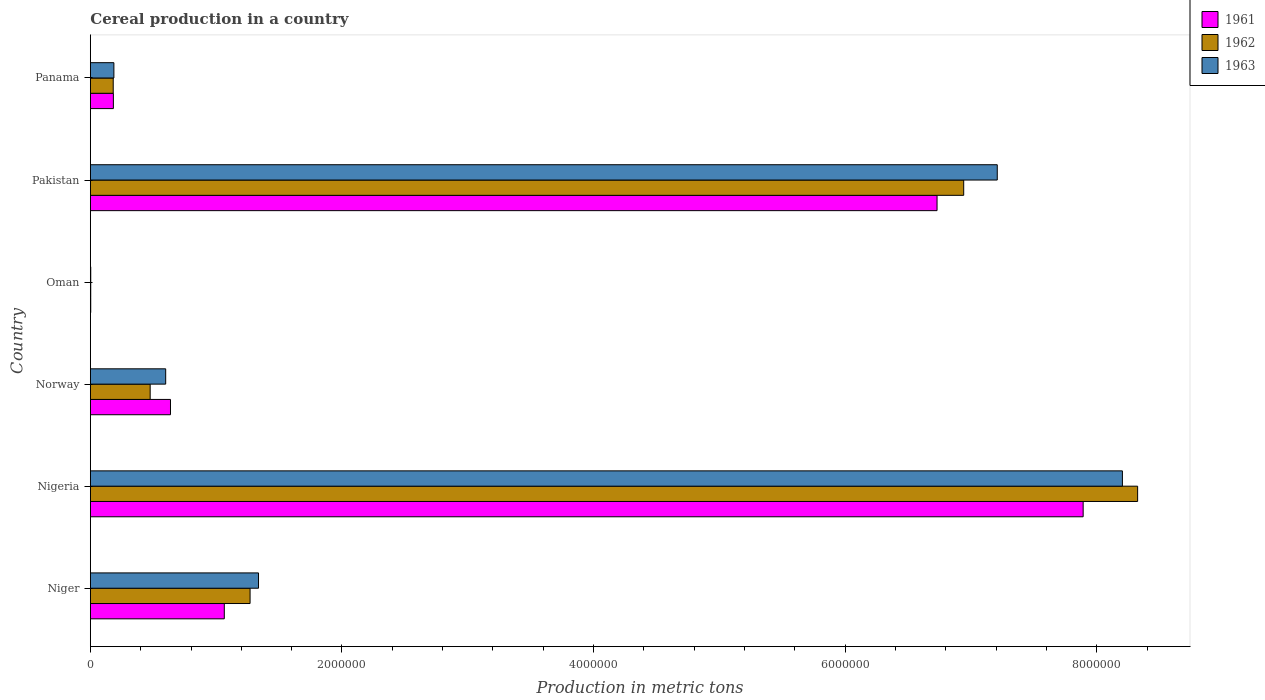How many different coloured bars are there?
Your answer should be very brief. 3. How many bars are there on the 6th tick from the top?
Keep it short and to the point. 3. What is the label of the 1st group of bars from the top?
Offer a very short reply. Panama. In how many cases, is the number of bars for a given country not equal to the number of legend labels?
Make the answer very short. 0. What is the total cereal production in 1961 in Panama?
Your response must be concise. 1.83e+05. Across all countries, what is the maximum total cereal production in 1963?
Keep it short and to the point. 8.20e+06. Across all countries, what is the minimum total cereal production in 1962?
Offer a terse response. 2900. In which country was the total cereal production in 1962 maximum?
Offer a very short reply. Nigeria. In which country was the total cereal production in 1961 minimum?
Keep it short and to the point. Oman. What is the total total cereal production in 1962 in the graph?
Give a very brief answer. 1.72e+07. What is the difference between the total cereal production in 1961 in Oman and that in Panama?
Offer a terse response. -1.80e+05. What is the difference between the total cereal production in 1962 in Norway and the total cereal production in 1963 in Niger?
Provide a short and direct response. -8.61e+05. What is the average total cereal production in 1963 per country?
Give a very brief answer. 2.92e+06. What is the difference between the total cereal production in 1962 and total cereal production in 1963 in Panama?
Offer a very short reply. -5407. In how many countries, is the total cereal production in 1961 greater than 6400000 metric tons?
Keep it short and to the point. 2. What is the ratio of the total cereal production in 1962 in Nigeria to that in Pakistan?
Provide a short and direct response. 1.2. Is the total cereal production in 1961 in Nigeria less than that in Panama?
Your answer should be very brief. No. Is the difference between the total cereal production in 1962 in Niger and Norway greater than the difference between the total cereal production in 1963 in Niger and Norway?
Give a very brief answer. Yes. What is the difference between the highest and the second highest total cereal production in 1963?
Give a very brief answer. 9.95e+05. What is the difference between the highest and the lowest total cereal production in 1963?
Ensure brevity in your answer.  8.20e+06. What does the 1st bar from the bottom in Pakistan represents?
Your answer should be compact. 1961. Is it the case that in every country, the sum of the total cereal production in 1961 and total cereal production in 1962 is greater than the total cereal production in 1963?
Ensure brevity in your answer.  Yes. Are all the bars in the graph horizontal?
Your answer should be compact. Yes. How many countries are there in the graph?
Your response must be concise. 6. What is the difference between two consecutive major ticks on the X-axis?
Your response must be concise. 2.00e+06. Are the values on the major ticks of X-axis written in scientific E-notation?
Give a very brief answer. No. Does the graph contain any zero values?
Provide a succinct answer. No. Where does the legend appear in the graph?
Your answer should be very brief. Top right. What is the title of the graph?
Offer a very short reply. Cereal production in a country. Does "1977" appear as one of the legend labels in the graph?
Offer a terse response. No. What is the label or title of the X-axis?
Offer a very short reply. Production in metric tons. What is the label or title of the Y-axis?
Provide a succinct answer. Country. What is the Production in metric tons of 1961 in Niger?
Make the answer very short. 1.06e+06. What is the Production in metric tons of 1962 in Niger?
Offer a terse response. 1.27e+06. What is the Production in metric tons in 1963 in Niger?
Your answer should be very brief. 1.34e+06. What is the Production in metric tons of 1961 in Nigeria?
Offer a terse response. 7.89e+06. What is the Production in metric tons of 1962 in Nigeria?
Your response must be concise. 8.32e+06. What is the Production in metric tons in 1963 in Nigeria?
Give a very brief answer. 8.20e+06. What is the Production in metric tons in 1961 in Norway?
Provide a succinct answer. 6.37e+05. What is the Production in metric tons of 1962 in Norway?
Offer a very short reply. 4.75e+05. What is the Production in metric tons in 1963 in Norway?
Offer a very short reply. 5.99e+05. What is the Production in metric tons of 1961 in Oman?
Ensure brevity in your answer.  2900. What is the Production in metric tons in 1962 in Oman?
Offer a very short reply. 2900. What is the Production in metric tons in 1963 in Oman?
Provide a succinct answer. 3000. What is the Production in metric tons of 1961 in Pakistan?
Your answer should be very brief. 6.73e+06. What is the Production in metric tons in 1962 in Pakistan?
Your answer should be compact. 6.94e+06. What is the Production in metric tons in 1963 in Pakistan?
Offer a terse response. 7.21e+06. What is the Production in metric tons of 1961 in Panama?
Keep it short and to the point. 1.83e+05. What is the Production in metric tons in 1962 in Panama?
Your answer should be very brief. 1.82e+05. What is the Production in metric tons of 1963 in Panama?
Your response must be concise. 1.87e+05. Across all countries, what is the maximum Production in metric tons of 1961?
Your answer should be very brief. 7.89e+06. Across all countries, what is the maximum Production in metric tons in 1962?
Give a very brief answer. 8.32e+06. Across all countries, what is the maximum Production in metric tons of 1963?
Keep it short and to the point. 8.20e+06. Across all countries, what is the minimum Production in metric tons of 1961?
Keep it short and to the point. 2900. Across all countries, what is the minimum Production in metric tons in 1962?
Keep it short and to the point. 2900. Across all countries, what is the minimum Production in metric tons of 1963?
Keep it short and to the point. 3000. What is the total Production in metric tons in 1961 in the graph?
Ensure brevity in your answer.  1.65e+07. What is the total Production in metric tons in 1962 in the graph?
Give a very brief answer. 1.72e+07. What is the total Production in metric tons in 1963 in the graph?
Your answer should be very brief. 1.75e+07. What is the difference between the Production in metric tons of 1961 in Niger and that in Nigeria?
Your answer should be very brief. -6.83e+06. What is the difference between the Production in metric tons in 1962 in Niger and that in Nigeria?
Provide a short and direct response. -7.05e+06. What is the difference between the Production in metric tons of 1963 in Niger and that in Nigeria?
Your answer should be very brief. -6.87e+06. What is the difference between the Production in metric tons of 1961 in Niger and that in Norway?
Provide a succinct answer. 4.28e+05. What is the difference between the Production in metric tons in 1962 in Niger and that in Norway?
Make the answer very short. 7.94e+05. What is the difference between the Production in metric tons of 1963 in Niger and that in Norway?
Offer a terse response. 7.38e+05. What is the difference between the Production in metric tons of 1961 in Niger and that in Oman?
Your answer should be compact. 1.06e+06. What is the difference between the Production in metric tons in 1962 in Niger and that in Oman?
Offer a very short reply. 1.27e+06. What is the difference between the Production in metric tons in 1963 in Niger and that in Oman?
Offer a terse response. 1.33e+06. What is the difference between the Production in metric tons of 1961 in Niger and that in Pakistan?
Your response must be concise. -5.67e+06. What is the difference between the Production in metric tons in 1962 in Niger and that in Pakistan?
Ensure brevity in your answer.  -5.67e+06. What is the difference between the Production in metric tons of 1963 in Niger and that in Pakistan?
Provide a succinct answer. -5.87e+06. What is the difference between the Production in metric tons in 1961 in Niger and that in Panama?
Ensure brevity in your answer.  8.82e+05. What is the difference between the Production in metric tons of 1962 in Niger and that in Panama?
Ensure brevity in your answer.  1.09e+06. What is the difference between the Production in metric tons of 1963 in Niger and that in Panama?
Ensure brevity in your answer.  1.15e+06. What is the difference between the Production in metric tons of 1961 in Nigeria and that in Norway?
Give a very brief answer. 7.25e+06. What is the difference between the Production in metric tons of 1962 in Nigeria and that in Norway?
Offer a terse response. 7.85e+06. What is the difference between the Production in metric tons in 1963 in Nigeria and that in Norway?
Provide a short and direct response. 7.60e+06. What is the difference between the Production in metric tons of 1961 in Nigeria and that in Oman?
Provide a short and direct response. 7.89e+06. What is the difference between the Production in metric tons of 1962 in Nigeria and that in Oman?
Your answer should be very brief. 8.32e+06. What is the difference between the Production in metric tons of 1963 in Nigeria and that in Oman?
Provide a succinct answer. 8.20e+06. What is the difference between the Production in metric tons of 1961 in Nigeria and that in Pakistan?
Give a very brief answer. 1.16e+06. What is the difference between the Production in metric tons in 1962 in Nigeria and that in Pakistan?
Ensure brevity in your answer.  1.38e+06. What is the difference between the Production in metric tons of 1963 in Nigeria and that in Pakistan?
Your response must be concise. 9.95e+05. What is the difference between the Production in metric tons of 1961 in Nigeria and that in Panama?
Offer a terse response. 7.71e+06. What is the difference between the Production in metric tons of 1962 in Nigeria and that in Panama?
Provide a succinct answer. 8.14e+06. What is the difference between the Production in metric tons of 1963 in Nigeria and that in Panama?
Offer a terse response. 8.02e+06. What is the difference between the Production in metric tons in 1961 in Norway and that in Oman?
Provide a succinct answer. 6.34e+05. What is the difference between the Production in metric tons of 1962 in Norway and that in Oman?
Give a very brief answer. 4.72e+05. What is the difference between the Production in metric tons of 1963 in Norway and that in Oman?
Provide a short and direct response. 5.96e+05. What is the difference between the Production in metric tons of 1961 in Norway and that in Pakistan?
Offer a terse response. -6.09e+06. What is the difference between the Production in metric tons of 1962 in Norway and that in Pakistan?
Keep it short and to the point. -6.47e+06. What is the difference between the Production in metric tons of 1963 in Norway and that in Pakistan?
Offer a terse response. -6.61e+06. What is the difference between the Production in metric tons in 1961 in Norway and that in Panama?
Your response must be concise. 4.54e+05. What is the difference between the Production in metric tons of 1962 in Norway and that in Panama?
Offer a terse response. 2.94e+05. What is the difference between the Production in metric tons of 1963 in Norway and that in Panama?
Provide a succinct answer. 4.12e+05. What is the difference between the Production in metric tons in 1961 in Oman and that in Pakistan?
Provide a succinct answer. -6.73e+06. What is the difference between the Production in metric tons of 1962 in Oman and that in Pakistan?
Provide a succinct answer. -6.94e+06. What is the difference between the Production in metric tons in 1963 in Oman and that in Pakistan?
Provide a short and direct response. -7.21e+06. What is the difference between the Production in metric tons of 1961 in Oman and that in Panama?
Keep it short and to the point. -1.80e+05. What is the difference between the Production in metric tons of 1962 in Oman and that in Panama?
Provide a short and direct response. -1.79e+05. What is the difference between the Production in metric tons of 1963 in Oman and that in Panama?
Make the answer very short. -1.84e+05. What is the difference between the Production in metric tons in 1961 in Pakistan and that in Panama?
Ensure brevity in your answer.  6.55e+06. What is the difference between the Production in metric tons in 1962 in Pakistan and that in Panama?
Provide a short and direct response. 6.76e+06. What is the difference between the Production in metric tons of 1963 in Pakistan and that in Panama?
Ensure brevity in your answer.  7.02e+06. What is the difference between the Production in metric tons of 1961 in Niger and the Production in metric tons of 1962 in Nigeria?
Provide a succinct answer. -7.26e+06. What is the difference between the Production in metric tons of 1961 in Niger and the Production in metric tons of 1963 in Nigeria?
Provide a succinct answer. -7.14e+06. What is the difference between the Production in metric tons in 1962 in Niger and the Production in metric tons in 1963 in Nigeria?
Give a very brief answer. -6.93e+06. What is the difference between the Production in metric tons in 1961 in Niger and the Production in metric tons in 1962 in Norway?
Your answer should be very brief. 5.89e+05. What is the difference between the Production in metric tons of 1961 in Niger and the Production in metric tons of 1963 in Norway?
Provide a succinct answer. 4.66e+05. What is the difference between the Production in metric tons in 1962 in Niger and the Production in metric tons in 1963 in Norway?
Your answer should be very brief. 6.71e+05. What is the difference between the Production in metric tons in 1961 in Niger and the Production in metric tons in 1962 in Oman?
Provide a short and direct response. 1.06e+06. What is the difference between the Production in metric tons in 1961 in Niger and the Production in metric tons in 1963 in Oman?
Offer a very short reply. 1.06e+06. What is the difference between the Production in metric tons in 1962 in Niger and the Production in metric tons in 1963 in Oman?
Ensure brevity in your answer.  1.27e+06. What is the difference between the Production in metric tons in 1961 in Niger and the Production in metric tons in 1962 in Pakistan?
Offer a very short reply. -5.88e+06. What is the difference between the Production in metric tons in 1961 in Niger and the Production in metric tons in 1963 in Pakistan?
Offer a very short reply. -6.14e+06. What is the difference between the Production in metric tons of 1962 in Niger and the Production in metric tons of 1963 in Pakistan?
Your answer should be very brief. -5.94e+06. What is the difference between the Production in metric tons of 1961 in Niger and the Production in metric tons of 1962 in Panama?
Keep it short and to the point. 8.83e+05. What is the difference between the Production in metric tons in 1961 in Niger and the Production in metric tons in 1963 in Panama?
Provide a short and direct response. 8.78e+05. What is the difference between the Production in metric tons of 1962 in Niger and the Production in metric tons of 1963 in Panama?
Offer a very short reply. 1.08e+06. What is the difference between the Production in metric tons in 1961 in Nigeria and the Production in metric tons in 1962 in Norway?
Give a very brief answer. 7.42e+06. What is the difference between the Production in metric tons in 1961 in Nigeria and the Production in metric tons in 1963 in Norway?
Keep it short and to the point. 7.29e+06. What is the difference between the Production in metric tons of 1962 in Nigeria and the Production in metric tons of 1963 in Norway?
Offer a very short reply. 7.73e+06. What is the difference between the Production in metric tons of 1961 in Nigeria and the Production in metric tons of 1962 in Oman?
Your answer should be compact. 7.89e+06. What is the difference between the Production in metric tons of 1961 in Nigeria and the Production in metric tons of 1963 in Oman?
Your response must be concise. 7.89e+06. What is the difference between the Production in metric tons of 1962 in Nigeria and the Production in metric tons of 1963 in Oman?
Your answer should be very brief. 8.32e+06. What is the difference between the Production in metric tons of 1961 in Nigeria and the Production in metric tons of 1962 in Pakistan?
Provide a short and direct response. 9.49e+05. What is the difference between the Production in metric tons in 1961 in Nigeria and the Production in metric tons in 1963 in Pakistan?
Offer a very short reply. 6.83e+05. What is the difference between the Production in metric tons of 1962 in Nigeria and the Production in metric tons of 1963 in Pakistan?
Your answer should be compact. 1.12e+06. What is the difference between the Production in metric tons in 1961 in Nigeria and the Production in metric tons in 1962 in Panama?
Your answer should be compact. 7.71e+06. What is the difference between the Production in metric tons of 1961 in Nigeria and the Production in metric tons of 1963 in Panama?
Offer a very short reply. 7.70e+06. What is the difference between the Production in metric tons of 1962 in Nigeria and the Production in metric tons of 1963 in Panama?
Offer a very short reply. 8.14e+06. What is the difference between the Production in metric tons in 1961 in Norway and the Production in metric tons in 1962 in Oman?
Ensure brevity in your answer.  6.34e+05. What is the difference between the Production in metric tons in 1961 in Norway and the Production in metric tons in 1963 in Oman?
Provide a short and direct response. 6.34e+05. What is the difference between the Production in metric tons of 1962 in Norway and the Production in metric tons of 1963 in Oman?
Offer a terse response. 4.72e+05. What is the difference between the Production in metric tons of 1961 in Norway and the Production in metric tons of 1962 in Pakistan?
Keep it short and to the point. -6.30e+06. What is the difference between the Production in metric tons in 1961 in Norway and the Production in metric tons in 1963 in Pakistan?
Your answer should be very brief. -6.57e+06. What is the difference between the Production in metric tons of 1962 in Norway and the Production in metric tons of 1963 in Pakistan?
Your answer should be compact. -6.73e+06. What is the difference between the Production in metric tons in 1961 in Norway and the Production in metric tons in 1962 in Panama?
Provide a succinct answer. 4.55e+05. What is the difference between the Production in metric tons of 1961 in Norway and the Production in metric tons of 1963 in Panama?
Provide a short and direct response. 4.50e+05. What is the difference between the Production in metric tons of 1962 in Norway and the Production in metric tons of 1963 in Panama?
Provide a short and direct response. 2.88e+05. What is the difference between the Production in metric tons of 1961 in Oman and the Production in metric tons of 1962 in Pakistan?
Your answer should be compact. -6.94e+06. What is the difference between the Production in metric tons of 1961 in Oman and the Production in metric tons of 1963 in Pakistan?
Make the answer very short. -7.21e+06. What is the difference between the Production in metric tons of 1962 in Oman and the Production in metric tons of 1963 in Pakistan?
Your response must be concise. -7.21e+06. What is the difference between the Production in metric tons in 1961 in Oman and the Production in metric tons in 1962 in Panama?
Provide a succinct answer. -1.79e+05. What is the difference between the Production in metric tons in 1961 in Oman and the Production in metric tons in 1963 in Panama?
Ensure brevity in your answer.  -1.84e+05. What is the difference between the Production in metric tons in 1962 in Oman and the Production in metric tons in 1963 in Panama?
Make the answer very short. -1.84e+05. What is the difference between the Production in metric tons of 1961 in Pakistan and the Production in metric tons of 1962 in Panama?
Your response must be concise. 6.55e+06. What is the difference between the Production in metric tons of 1961 in Pakistan and the Production in metric tons of 1963 in Panama?
Offer a terse response. 6.54e+06. What is the difference between the Production in metric tons of 1962 in Pakistan and the Production in metric tons of 1963 in Panama?
Make the answer very short. 6.75e+06. What is the average Production in metric tons of 1961 per country?
Ensure brevity in your answer.  2.75e+06. What is the average Production in metric tons in 1962 per country?
Your answer should be compact. 2.87e+06. What is the average Production in metric tons of 1963 per country?
Keep it short and to the point. 2.92e+06. What is the difference between the Production in metric tons in 1961 and Production in metric tons in 1962 in Niger?
Provide a succinct answer. -2.05e+05. What is the difference between the Production in metric tons in 1961 and Production in metric tons in 1963 in Niger?
Give a very brief answer. -2.72e+05. What is the difference between the Production in metric tons in 1962 and Production in metric tons in 1963 in Niger?
Provide a succinct answer. -6.71e+04. What is the difference between the Production in metric tons in 1961 and Production in metric tons in 1962 in Nigeria?
Give a very brief answer. -4.33e+05. What is the difference between the Production in metric tons of 1961 and Production in metric tons of 1963 in Nigeria?
Ensure brevity in your answer.  -3.12e+05. What is the difference between the Production in metric tons of 1962 and Production in metric tons of 1963 in Nigeria?
Provide a short and direct response. 1.21e+05. What is the difference between the Production in metric tons of 1961 and Production in metric tons of 1962 in Norway?
Provide a succinct answer. 1.61e+05. What is the difference between the Production in metric tons in 1961 and Production in metric tons in 1963 in Norway?
Provide a short and direct response. 3.81e+04. What is the difference between the Production in metric tons in 1962 and Production in metric tons in 1963 in Norway?
Your answer should be very brief. -1.23e+05. What is the difference between the Production in metric tons of 1961 and Production in metric tons of 1963 in Oman?
Keep it short and to the point. -100. What is the difference between the Production in metric tons in 1962 and Production in metric tons in 1963 in Oman?
Provide a succinct answer. -100. What is the difference between the Production in metric tons of 1961 and Production in metric tons of 1962 in Pakistan?
Your answer should be very brief. -2.12e+05. What is the difference between the Production in metric tons in 1961 and Production in metric tons in 1963 in Pakistan?
Your answer should be compact. -4.79e+05. What is the difference between the Production in metric tons of 1962 and Production in metric tons of 1963 in Pakistan?
Keep it short and to the point. -2.67e+05. What is the difference between the Production in metric tons in 1961 and Production in metric tons in 1962 in Panama?
Provide a short and direct response. 1297. What is the difference between the Production in metric tons in 1961 and Production in metric tons in 1963 in Panama?
Offer a very short reply. -4110. What is the difference between the Production in metric tons in 1962 and Production in metric tons in 1963 in Panama?
Offer a very short reply. -5407. What is the ratio of the Production in metric tons in 1961 in Niger to that in Nigeria?
Make the answer very short. 0.13. What is the ratio of the Production in metric tons of 1962 in Niger to that in Nigeria?
Your answer should be very brief. 0.15. What is the ratio of the Production in metric tons in 1963 in Niger to that in Nigeria?
Your response must be concise. 0.16. What is the ratio of the Production in metric tons of 1961 in Niger to that in Norway?
Offer a terse response. 1.67. What is the ratio of the Production in metric tons of 1962 in Niger to that in Norway?
Keep it short and to the point. 2.67. What is the ratio of the Production in metric tons in 1963 in Niger to that in Norway?
Your response must be concise. 2.23. What is the ratio of the Production in metric tons of 1961 in Niger to that in Oman?
Keep it short and to the point. 367.08. What is the ratio of the Production in metric tons in 1962 in Niger to that in Oman?
Make the answer very short. 437.72. What is the ratio of the Production in metric tons of 1963 in Niger to that in Oman?
Ensure brevity in your answer.  445.48. What is the ratio of the Production in metric tons of 1961 in Niger to that in Pakistan?
Your response must be concise. 0.16. What is the ratio of the Production in metric tons of 1962 in Niger to that in Pakistan?
Make the answer very short. 0.18. What is the ratio of the Production in metric tons in 1963 in Niger to that in Pakistan?
Your response must be concise. 0.19. What is the ratio of the Production in metric tons in 1961 in Niger to that in Panama?
Provide a short and direct response. 5.82. What is the ratio of the Production in metric tons of 1962 in Niger to that in Panama?
Offer a very short reply. 6.99. What is the ratio of the Production in metric tons of 1963 in Niger to that in Panama?
Your answer should be compact. 7.15. What is the ratio of the Production in metric tons in 1961 in Nigeria to that in Norway?
Make the answer very short. 12.39. What is the ratio of the Production in metric tons of 1962 in Nigeria to that in Norway?
Offer a terse response. 17.51. What is the ratio of the Production in metric tons of 1963 in Nigeria to that in Norway?
Make the answer very short. 13.7. What is the ratio of the Production in metric tons of 1961 in Nigeria to that in Oman?
Give a very brief answer. 2721.03. What is the ratio of the Production in metric tons of 1962 in Nigeria to that in Oman?
Provide a succinct answer. 2870.34. What is the ratio of the Production in metric tons of 1963 in Nigeria to that in Oman?
Your answer should be compact. 2734.33. What is the ratio of the Production in metric tons of 1961 in Nigeria to that in Pakistan?
Make the answer very short. 1.17. What is the ratio of the Production in metric tons in 1962 in Nigeria to that in Pakistan?
Make the answer very short. 1.2. What is the ratio of the Production in metric tons of 1963 in Nigeria to that in Pakistan?
Ensure brevity in your answer.  1.14. What is the ratio of the Production in metric tons of 1961 in Nigeria to that in Panama?
Offer a terse response. 43.15. What is the ratio of the Production in metric tons in 1962 in Nigeria to that in Panama?
Your answer should be compact. 45.84. What is the ratio of the Production in metric tons in 1963 in Nigeria to that in Panama?
Provide a short and direct response. 43.87. What is the ratio of the Production in metric tons of 1961 in Norway to that in Oman?
Your response must be concise. 219.6. What is the ratio of the Production in metric tons in 1962 in Norway to that in Oman?
Your response must be concise. 163.93. What is the ratio of the Production in metric tons of 1963 in Norway to that in Oman?
Ensure brevity in your answer.  199.58. What is the ratio of the Production in metric tons of 1961 in Norway to that in Pakistan?
Provide a succinct answer. 0.09. What is the ratio of the Production in metric tons in 1962 in Norway to that in Pakistan?
Give a very brief answer. 0.07. What is the ratio of the Production in metric tons in 1963 in Norway to that in Pakistan?
Offer a very short reply. 0.08. What is the ratio of the Production in metric tons in 1961 in Norway to that in Panama?
Offer a very short reply. 3.48. What is the ratio of the Production in metric tons of 1962 in Norway to that in Panama?
Offer a terse response. 2.62. What is the ratio of the Production in metric tons in 1963 in Norway to that in Panama?
Make the answer very short. 3.2. What is the ratio of the Production in metric tons of 1961 in Oman to that in Pakistan?
Ensure brevity in your answer.  0. What is the ratio of the Production in metric tons of 1961 in Oman to that in Panama?
Offer a very short reply. 0.02. What is the ratio of the Production in metric tons of 1962 in Oman to that in Panama?
Offer a very short reply. 0.02. What is the ratio of the Production in metric tons of 1963 in Oman to that in Panama?
Give a very brief answer. 0.02. What is the ratio of the Production in metric tons of 1961 in Pakistan to that in Panama?
Provide a succinct answer. 36.8. What is the ratio of the Production in metric tons of 1962 in Pakistan to that in Panama?
Ensure brevity in your answer.  38.23. What is the ratio of the Production in metric tons of 1963 in Pakistan to that in Panama?
Offer a terse response. 38.55. What is the difference between the highest and the second highest Production in metric tons of 1961?
Offer a very short reply. 1.16e+06. What is the difference between the highest and the second highest Production in metric tons in 1962?
Ensure brevity in your answer.  1.38e+06. What is the difference between the highest and the second highest Production in metric tons of 1963?
Your response must be concise. 9.95e+05. What is the difference between the highest and the lowest Production in metric tons in 1961?
Provide a short and direct response. 7.89e+06. What is the difference between the highest and the lowest Production in metric tons in 1962?
Provide a short and direct response. 8.32e+06. What is the difference between the highest and the lowest Production in metric tons in 1963?
Ensure brevity in your answer.  8.20e+06. 